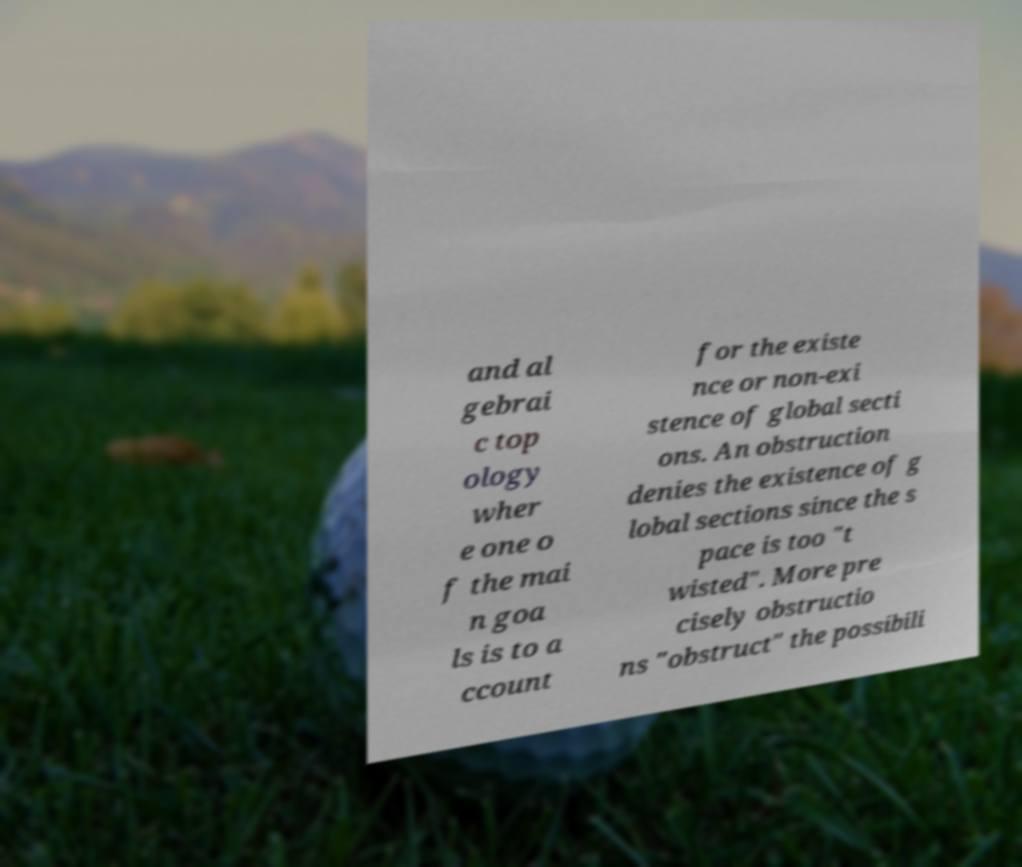Can you read and provide the text displayed in the image?This photo seems to have some interesting text. Can you extract and type it out for me? and al gebrai c top ology wher e one o f the mai n goa ls is to a ccount for the existe nce or non-exi stence of global secti ons. An obstruction denies the existence of g lobal sections since the s pace is too "t wisted". More pre cisely obstructio ns "obstruct" the possibili 